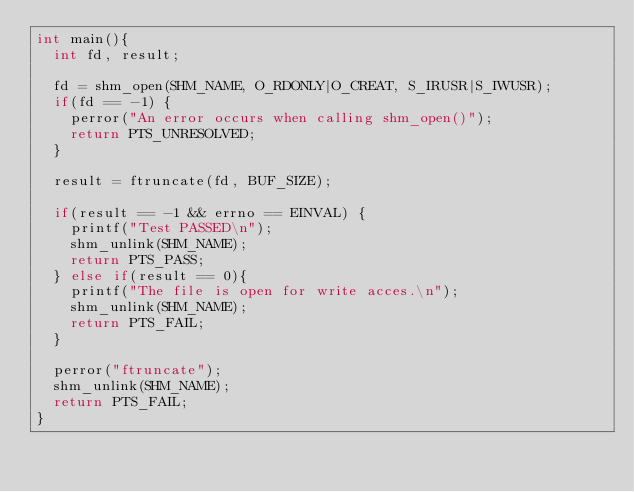<code> <loc_0><loc_0><loc_500><loc_500><_C_>int main(){
	int fd, result;

	fd = shm_open(SHM_NAME, O_RDONLY|O_CREAT, S_IRUSR|S_IWUSR);
	if(fd == -1) {
		perror("An error occurs when calling shm_open()");
		return PTS_UNRESOLVED;
	}

	result = ftruncate(fd, BUF_SIZE);

	if(result == -1 && errno == EINVAL) {
		printf("Test PASSED\n");
		shm_unlink(SHM_NAME);
		return PTS_PASS;
	} else if(result == 0){
		printf("The file is open for write acces.\n");
		shm_unlink(SHM_NAME);
		return PTS_FAIL;
	}

	perror("ftruncate");
	shm_unlink(SHM_NAME);
	return PTS_FAIL;
}
       
</code> 